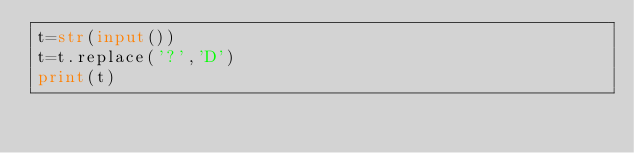Convert code to text. <code><loc_0><loc_0><loc_500><loc_500><_Python_>t=str(input())
t=t.replace('?','D')
print(t)</code> 